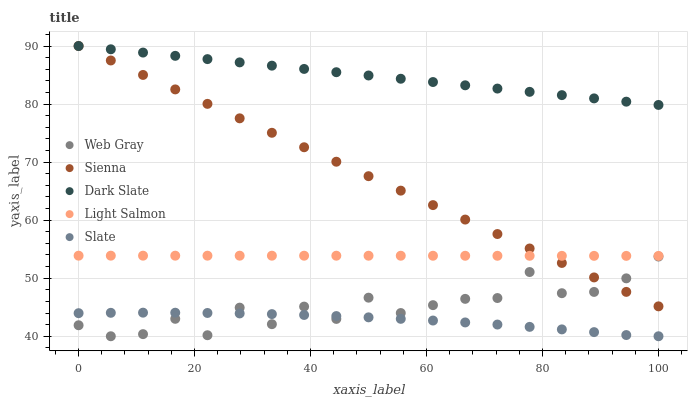Does Slate have the minimum area under the curve?
Answer yes or no. Yes. Does Dark Slate have the maximum area under the curve?
Answer yes or no. Yes. Does Light Salmon have the minimum area under the curve?
Answer yes or no. No. Does Light Salmon have the maximum area under the curve?
Answer yes or no. No. Is Dark Slate the smoothest?
Answer yes or no. Yes. Is Web Gray the roughest?
Answer yes or no. Yes. Is Light Salmon the smoothest?
Answer yes or no. No. Is Light Salmon the roughest?
Answer yes or no. No. Does Web Gray have the lowest value?
Answer yes or no. Yes. Does Light Salmon have the lowest value?
Answer yes or no. No. Does Dark Slate have the highest value?
Answer yes or no. Yes. Does Light Salmon have the highest value?
Answer yes or no. No. Is Web Gray less than Light Salmon?
Answer yes or no. Yes. Is Light Salmon greater than Web Gray?
Answer yes or no. Yes. Does Sienna intersect Light Salmon?
Answer yes or no. Yes. Is Sienna less than Light Salmon?
Answer yes or no. No. Is Sienna greater than Light Salmon?
Answer yes or no. No. Does Web Gray intersect Light Salmon?
Answer yes or no. No. 